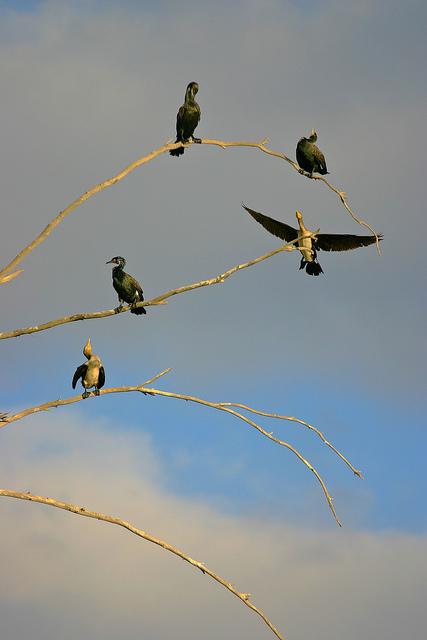How many birds are there?
Be succinct. 5. How many of the birds have their wings spread wide open?
Write a very short answer. 1. Are these birds of the same specie?
Quick response, please. Yes. 